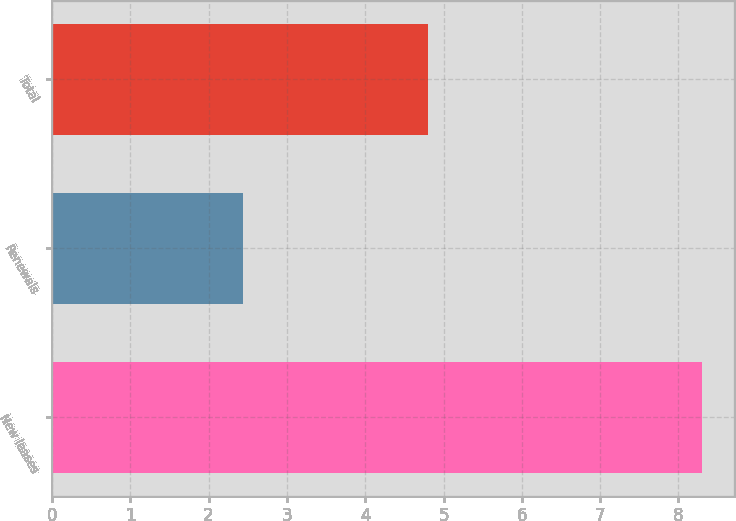Convert chart to OTSL. <chart><loc_0><loc_0><loc_500><loc_500><bar_chart><fcel>New leases<fcel>Renewals<fcel>Total<nl><fcel>8.3<fcel>2.44<fcel>4.8<nl></chart> 